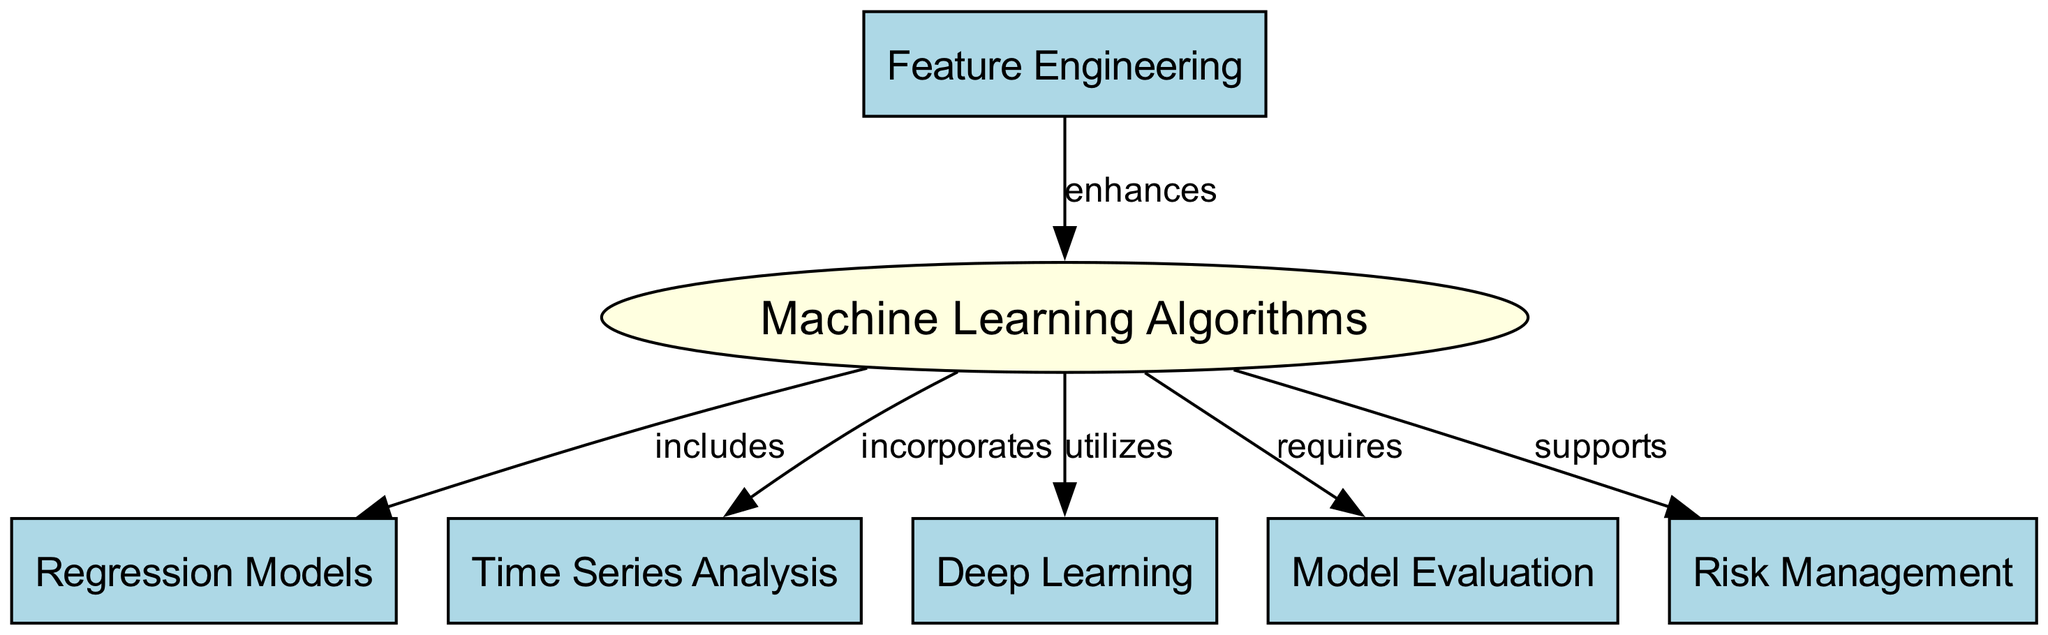What is the main node in the diagram? The diagram features "Machine Learning Algorithms" as the central node, which is highlighted with an ellipse shape and identified with a different fill color.
Answer: Machine Learning Algorithms How many nodes are present in the diagram? By counting the unique nodes listed in the diagram, there are a total of six nodes, including "Machine Learning Algorithms" and the five other associated concepts.
Answer: 6 Which node is included under "Machine Learning Algorithms"? The relationship indicates that "Regression Models" is one of the components that falls under the broader category of "Machine Learning Algorithms."
Answer: Regression Models What does "Feature Engineering" do in the context of the diagram? "Feature Engineering" enhances the effectiveness of "Machine Learning Algorithms," indicating its supportive role in improving predictive modeling performance.
Answer: enhances What type of analysis is incorporated in the "Machine Learning Algorithms"? The diagram shows that "Time Series Analysis" is a method incorporated into "Machine Learning Algorithms," suggesting its importance in analyzing sequential data.
Answer: Time Series Analysis Which node is required as part of the "Machine Learning Algorithms"? According to the diagram, "Model Evaluation" is established as a requisite aspect necessary for functioning "Machine Learning Algorithms."
Answer: Model Evaluation Describe the relationship between "Risk Management" and "Machine Learning Algorithms". The diagram specifies that "Risk Management" supports "Machine Learning Algorithms," implying its foundational role in assessing the potential risks related to predictive modeling.
Answer: supports What node utilizes the "Machine Learning Algorithms"? The diagram observes that "Deep Learning" utilizes "Machine Learning Algorithms," highlighting its dependence on these algorithms for advanced computational processes.
Answer: Deep Learning Explain the connection between "Feature Engineering" and "Machine Learning Algorithms". Not only does "Feature Engineering" enhance "Machine Learning Algorithms," but it also suggests that carefully crafted features can significantly improve the effectiveness and accuracy of these algorithms in predictive modeling.
Answer: enhances 